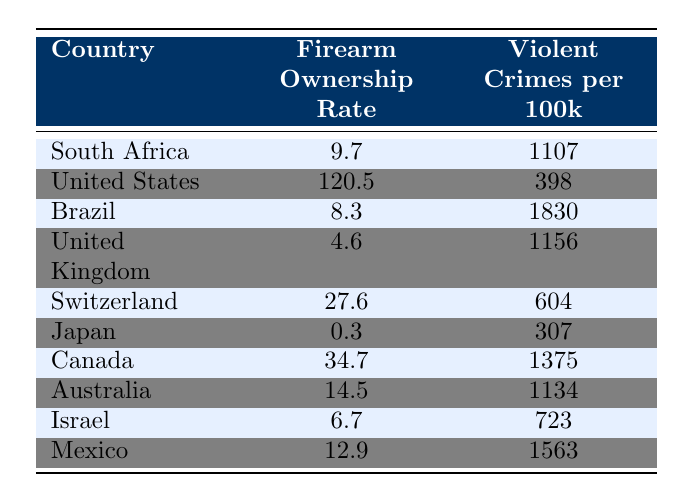What is the firearm ownership rate in South Africa? The table states that South Africa has a firearm ownership rate of 9.7.
Answer: 9.7 Which country has the highest rate of firearm ownership? According to the table, the United States has the highest firearm ownership rate at 120.5.
Answer: United States What is the violent crime rate per 100k in Brazil? The table shows that Brazil has a violent crime rate of 1830 per 100k.
Answer: 1830 Is the firearm ownership rate in Japan higher than that in the United Kingdom? Japan's firearm ownership rate is 0.3 while the United Kingdom's is 4.6; thus, Japan's rate is lower.
Answer: No What is the difference in the violent crime rates between South Africa and Canada? South Africa's rate is 1107 and Canada's is 1375; the difference is 1375 - 1107 = 268.
Answer: 268 What is the average firearm ownership rate for the countries listed? Add all the firearm ownership rates: 9.7 + 120.5 + 8.3 + 4.6 + 27.6 + 0.3 + 34.7 + 14.5 + 6.7 + 12.9 = 229.8, then divide by 10: 229.8 / 10 = 22.98.
Answer: 22.98 Is it true that the violent crime rate in the United States is lower than that in Brazil? The United States has a violent crime rate of 398, while Brazil’s is 1830, which means the United States' rate is indeed lower.
Answer: Yes Which country has a higher violent crime rate: Australia or Israel? Australia's rate is 1134, while Israel's is 723; since 1134 > 723, Australia has a higher rate.
Answer: Australia Which country has the lowest violent crime rate among the listed nations? The table shows that Japan has the lowest violent crime rate at 307 per 100k.
Answer: Japan How many countries have a firearm ownership rate above 10? The countries with rates above 10 are the United States (120.5), Canada (34.7), and Australia (14.5). This makes a total of 3 countries.
Answer: 3 